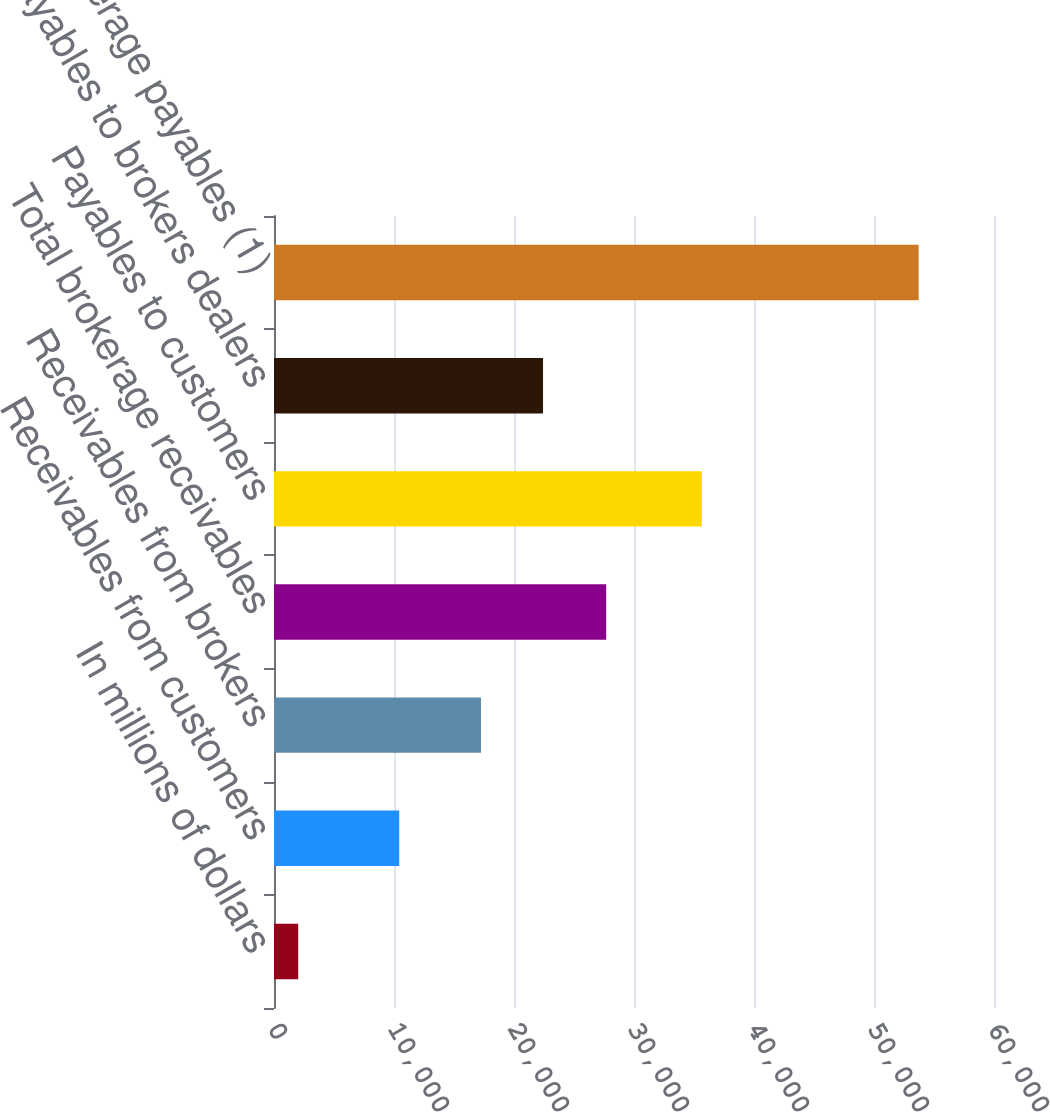Convert chart. <chart><loc_0><loc_0><loc_500><loc_500><bar_chart><fcel>In millions of dollars<fcel>Receivables from customers<fcel>Receivables from brokers<fcel>Total brokerage receivables<fcel>Payables to customers<fcel>Payables to brokers dealers<fcel>Total brokerage payables (1)<nl><fcel>2015<fcel>10435<fcel>17248<fcel>27683<fcel>35653<fcel>22418.7<fcel>53722<nl></chart> 